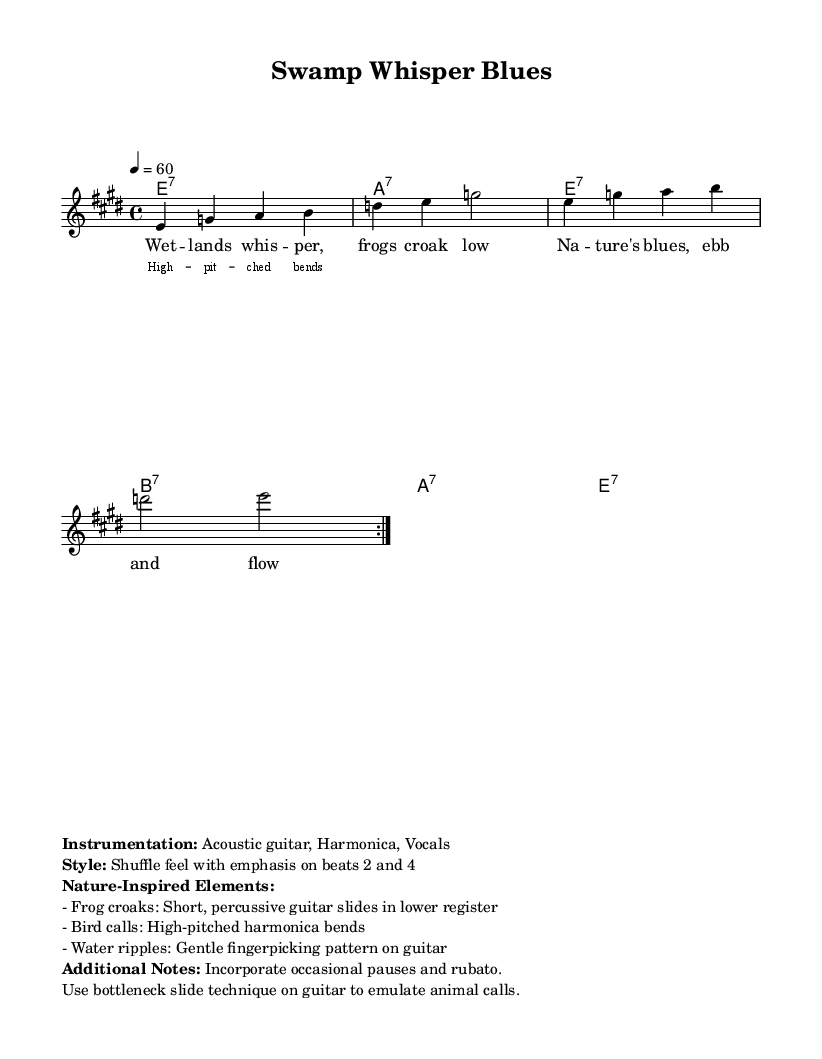What is the key signature of this music? The key signature indicates E major, which has four sharps (F#, C#, G#, D#). This information is typically found at the beginning of the staff in sheet music.
Answer: E major What is the time signature of this piece? The time signature shown at the beginning is 4/4, meaning there are four beats in each measure and the quarter note receives one beat.
Answer: 4/4 What is the tempo marking of the music? The tempo marking indicates 60 beats per minute, which is shown as "4 = 60" in the code. This means that a quarter note is played at that rate.
Answer: 60 How many measures are in the repeated section? The repeated section consists of 8 measures, as there are four measures in each volta, and it repeats twice. This is identified by the repeat markings in the melody section.
Answer: 8 measures What technique is suggested for the guitar to emulate animal calls? The sheet music suggests using bottleneck slide technique to imitate animal calls. This can be inferred from the additional notes section that mention how to incorporate natural sounds.
Answer: Bottleneck slide What keys are indicated for the guitar chords? The chord names shown indicate E7, A7, and B7 for the guitar part, which are fundamental chords in the blues genre and are specified in the chord mode section.
Answer: E7, A7, B7 What specific nature-inspired elements are used in the music? The music incorporates frog croaks, bird calls, and water ripples as nature-inspired elements. This information can be found in the additional notes section.
Answer: Frog croaks, bird calls, water ripples 